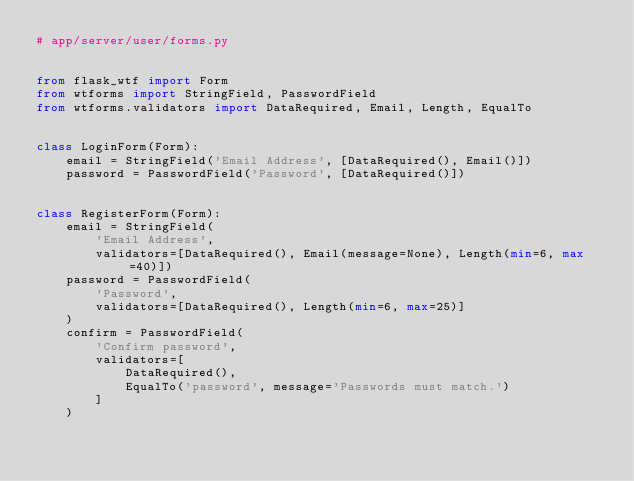Convert code to text. <code><loc_0><loc_0><loc_500><loc_500><_Python_># app/server/user/forms.py


from flask_wtf import Form
from wtforms import StringField, PasswordField
from wtforms.validators import DataRequired, Email, Length, EqualTo


class LoginForm(Form):
    email = StringField('Email Address', [DataRequired(), Email()])
    password = PasswordField('Password', [DataRequired()])


class RegisterForm(Form):
    email = StringField(
        'Email Address',
        validators=[DataRequired(), Email(message=None), Length(min=6, max=40)])
    password = PasswordField(
        'Password',
        validators=[DataRequired(), Length(min=6, max=25)]
    )
    confirm = PasswordField(
        'Confirm password',
        validators=[
            DataRequired(),
            EqualTo('password', message='Passwords must match.')
        ]
    )
</code> 